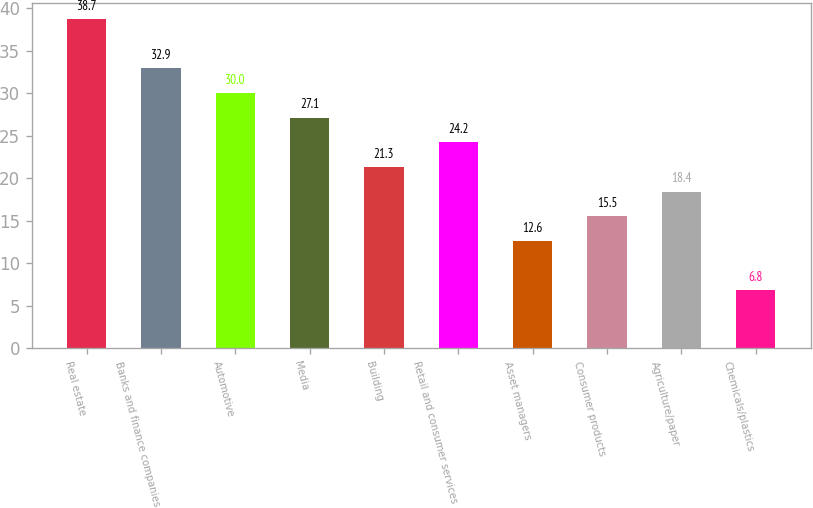Convert chart. <chart><loc_0><loc_0><loc_500><loc_500><bar_chart><fcel>Real estate<fcel>Banks and finance companies<fcel>Automotive<fcel>Media<fcel>Building<fcel>Retail and consumer services<fcel>Asset managers<fcel>Consumer products<fcel>Agriculture/paper<fcel>Chemicals/plastics<nl><fcel>38.7<fcel>32.9<fcel>30<fcel>27.1<fcel>21.3<fcel>24.2<fcel>12.6<fcel>15.5<fcel>18.4<fcel>6.8<nl></chart> 